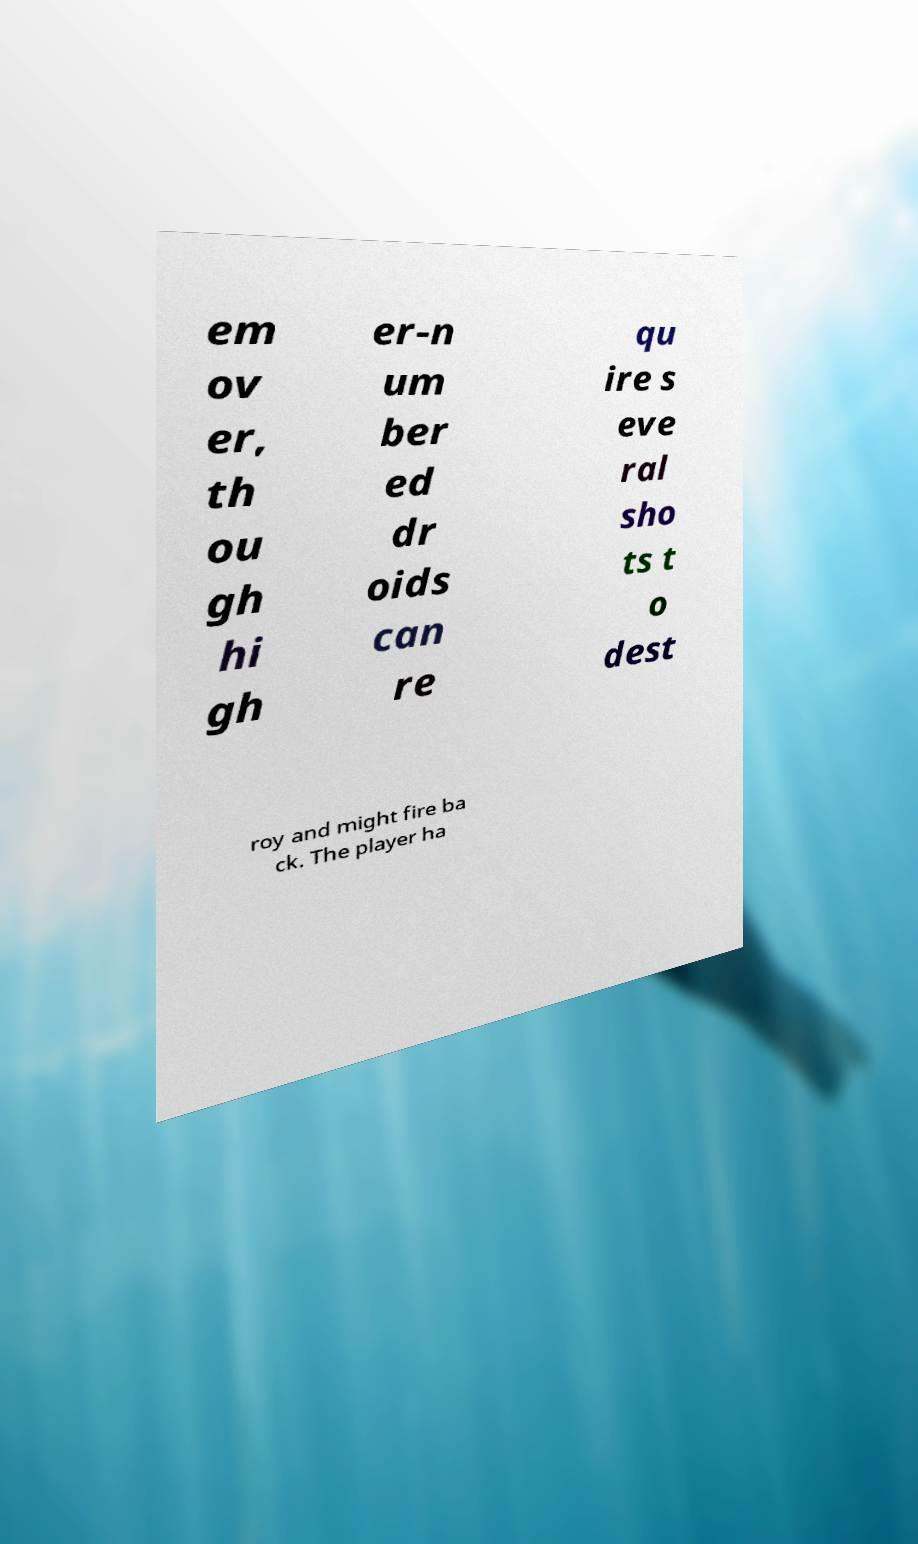What messages or text are displayed in this image? I need them in a readable, typed format. em ov er, th ou gh hi gh er-n um ber ed dr oids can re qu ire s eve ral sho ts t o dest roy and might fire ba ck. The player ha 